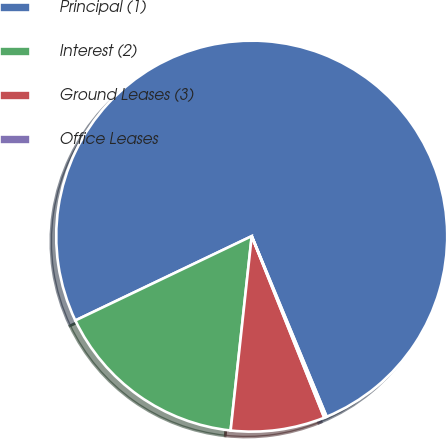Convert chart to OTSL. <chart><loc_0><loc_0><loc_500><loc_500><pie_chart><fcel>Principal (1)<fcel>Interest (2)<fcel>Ground Leases (3)<fcel>Office Leases<nl><fcel>75.83%<fcel>16.18%<fcel>7.77%<fcel>0.21%<nl></chart> 